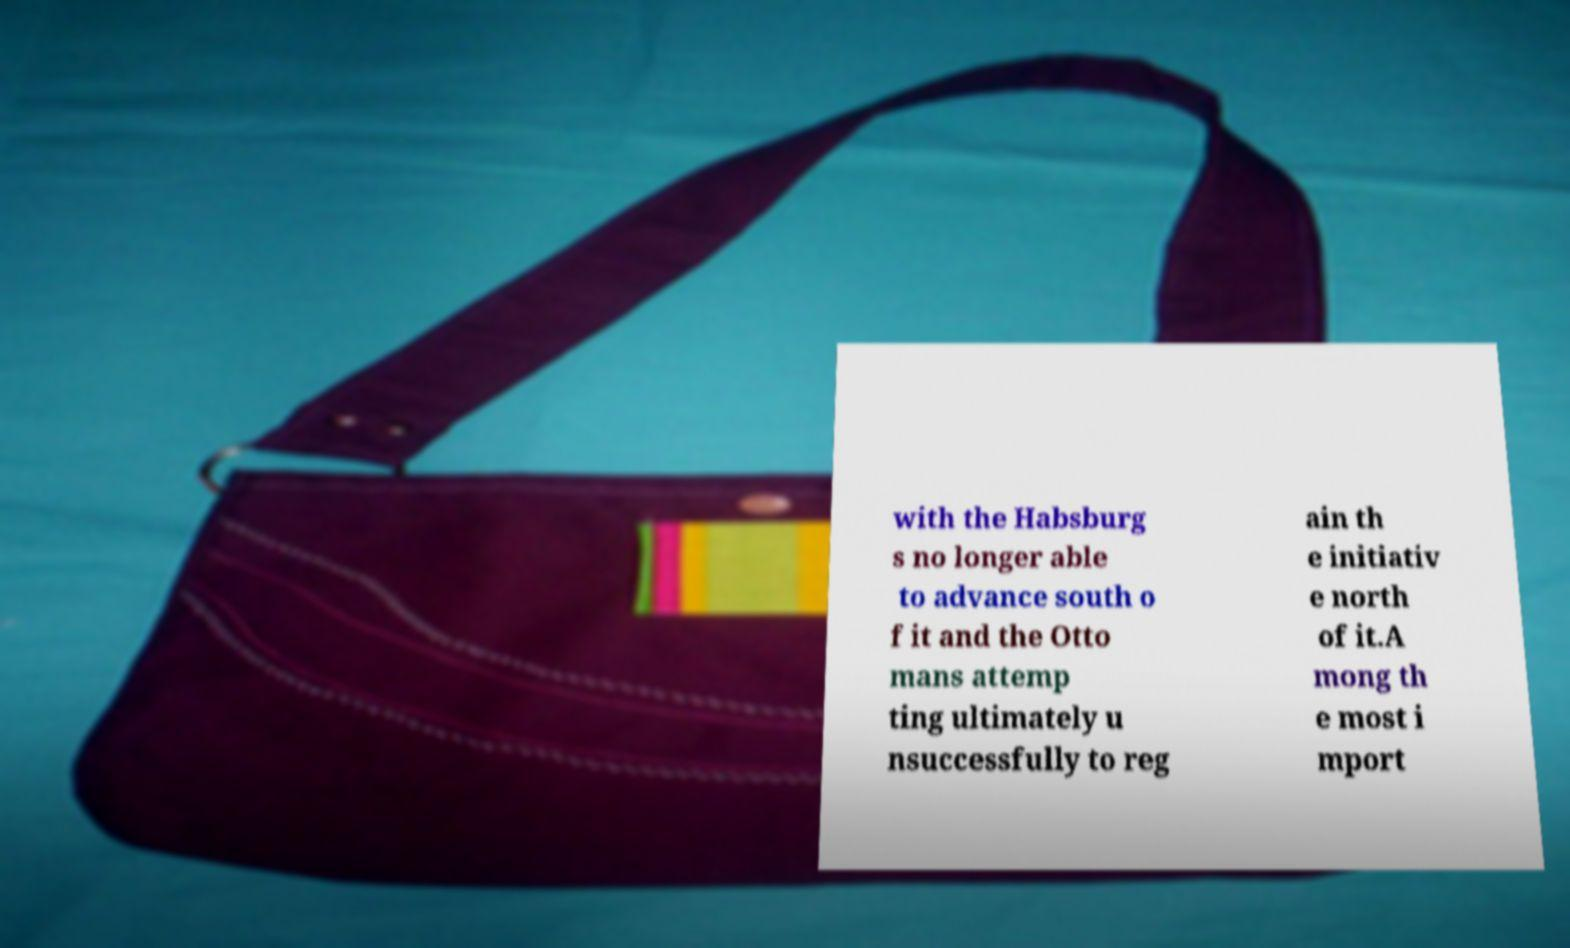There's text embedded in this image that I need extracted. Can you transcribe it verbatim? with the Habsburg s no longer able to advance south o f it and the Otto mans attemp ting ultimately u nsuccessfully to reg ain th e initiativ e north of it.A mong th e most i mport 